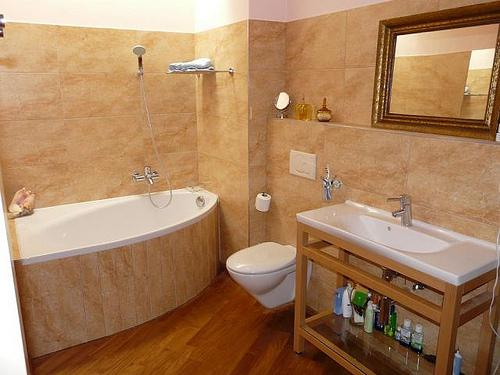Question: what is in the bath room?
Choices:
A. Toilet.
B. Sink.
C. Towels.
D. A tub.
Answer with the letter. Answer: D Question: who is in the tub?
Choices:
A. 1 man.
B. 1 woman.
C. Nobody.
D. A baby.
Answer with the letter. Answer: C Question: what is on the bottom sink?
Choices:
A. Toilet paper.
B. Towels.
C. Soaps.
D. Magazine.
Answer with the letter. Answer: C Question: when is the light off?
Choices:
A. Never.
B. During the day.
C. At lunch.
D. Soon.
Answer with the letter. Answer: D Question: why is the floor brown?
Choices:
A. It's painted that color.
B. It's the color of the wood.
C. It's carpeting.
D. It's dirty.
Answer with the letter. Answer: B 